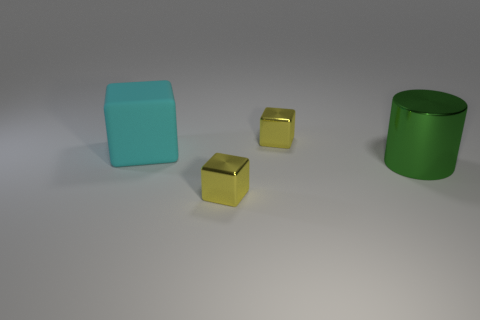Subtract all cyan cylinders. How many yellow blocks are left? 2 Subtract all cyan cubes. How many cubes are left? 2 Add 4 big metal cylinders. How many objects exist? 8 Subtract all cubes. How many objects are left? 1 Subtract all purple blocks. Subtract all brown cylinders. How many blocks are left? 3 Add 2 large cyan things. How many large cyan things exist? 3 Subtract 0 red cubes. How many objects are left? 4 Subtract all large cyan matte things. Subtract all big shiny objects. How many objects are left? 2 Add 1 large matte blocks. How many large matte blocks are left? 2 